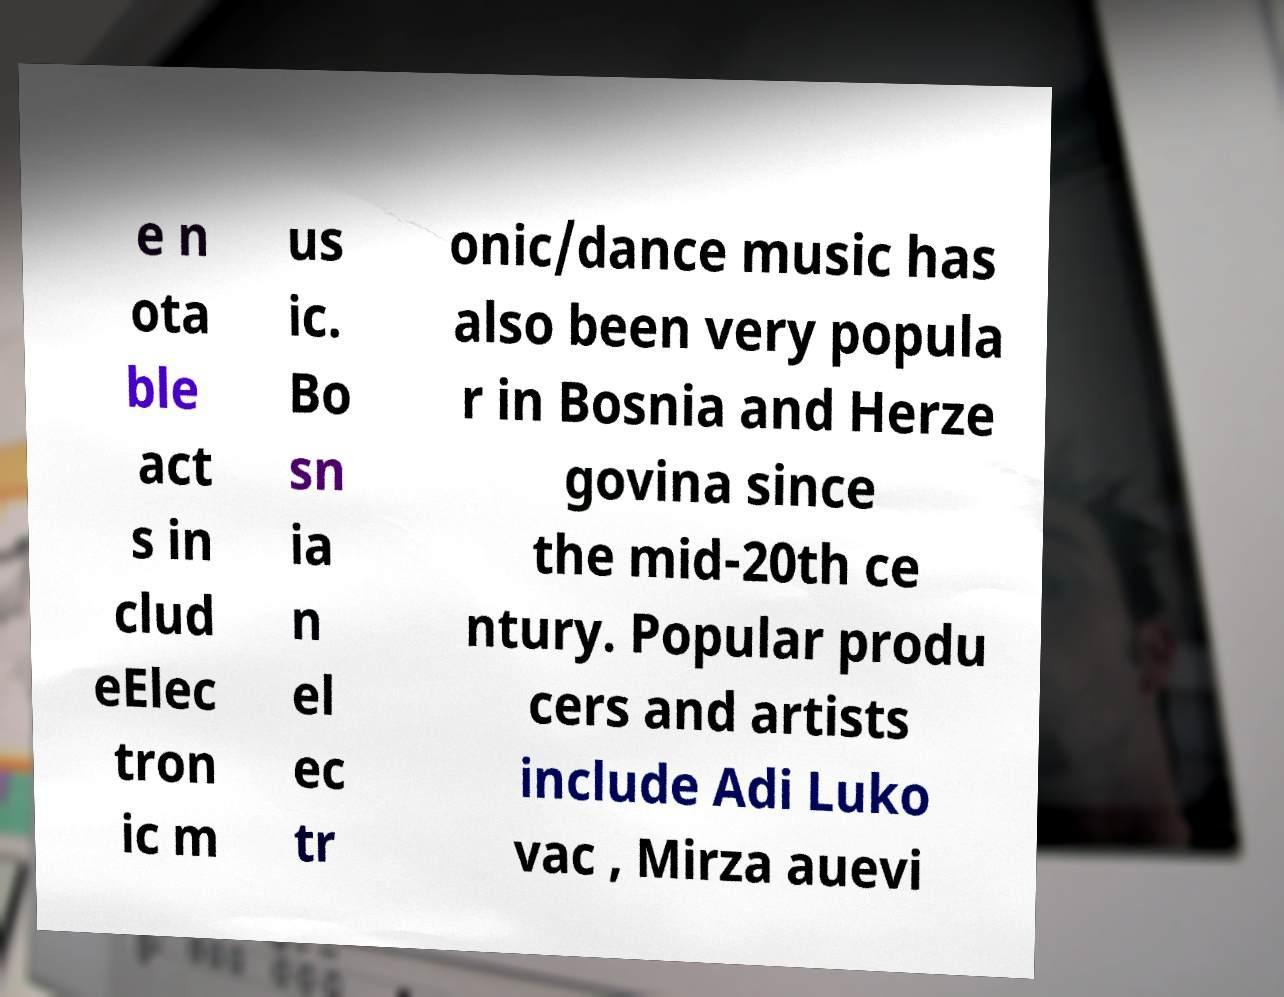Can you read and provide the text displayed in the image?This photo seems to have some interesting text. Can you extract and type it out for me? e n ota ble act s in clud eElec tron ic m us ic. Bo sn ia n el ec tr onic/dance music has also been very popula r in Bosnia and Herze govina since the mid-20th ce ntury. Popular produ cers and artists include Adi Luko vac , Mirza auevi 